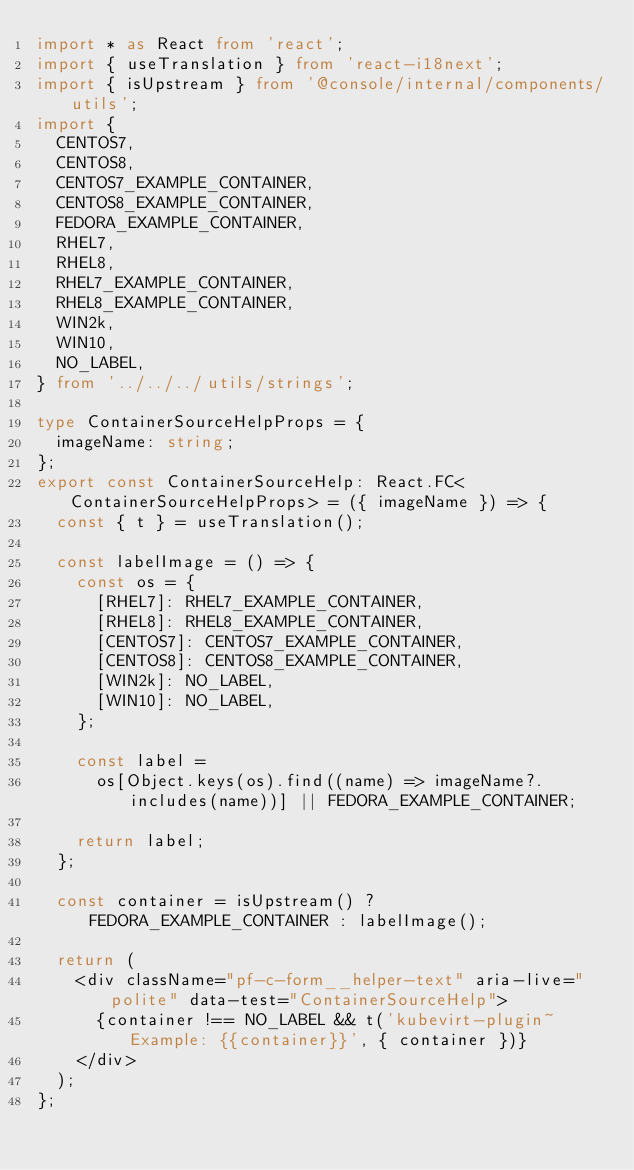<code> <loc_0><loc_0><loc_500><loc_500><_TypeScript_>import * as React from 'react';
import { useTranslation } from 'react-i18next';
import { isUpstream } from '@console/internal/components/utils';
import {
  CENTOS7,
  CENTOS8,
  CENTOS7_EXAMPLE_CONTAINER,
  CENTOS8_EXAMPLE_CONTAINER,
  FEDORA_EXAMPLE_CONTAINER,
  RHEL7,
  RHEL8,
  RHEL7_EXAMPLE_CONTAINER,
  RHEL8_EXAMPLE_CONTAINER,
  WIN2k,
  WIN10,
  NO_LABEL,
} from '../../../utils/strings';

type ContainerSourceHelpProps = {
  imageName: string;
};
export const ContainerSourceHelp: React.FC<ContainerSourceHelpProps> = ({ imageName }) => {
  const { t } = useTranslation();

  const labelImage = () => {
    const os = {
      [RHEL7]: RHEL7_EXAMPLE_CONTAINER,
      [RHEL8]: RHEL8_EXAMPLE_CONTAINER,
      [CENTOS7]: CENTOS7_EXAMPLE_CONTAINER,
      [CENTOS8]: CENTOS8_EXAMPLE_CONTAINER,
      [WIN2k]: NO_LABEL,
      [WIN10]: NO_LABEL,
    };

    const label =
      os[Object.keys(os).find((name) => imageName?.includes(name))] || FEDORA_EXAMPLE_CONTAINER;

    return label;
  };

  const container = isUpstream() ? FEDORA_EXAMPLE_CONTAINER : labelImage();

  return (
    <div className="pf-c-form__helper-text" aria-live="polite" data-test="ContainerSourceHelp">
      {container !== NO_LABEL && t('kubevirt-plugin~Example: {{container}}', { container })}
    </div>
  );
};
</code> 